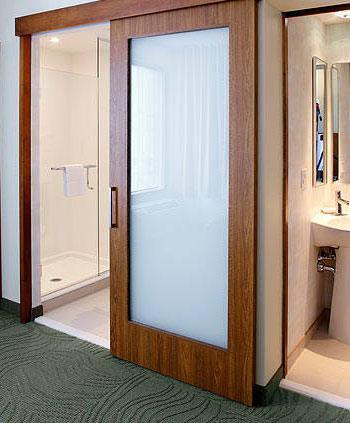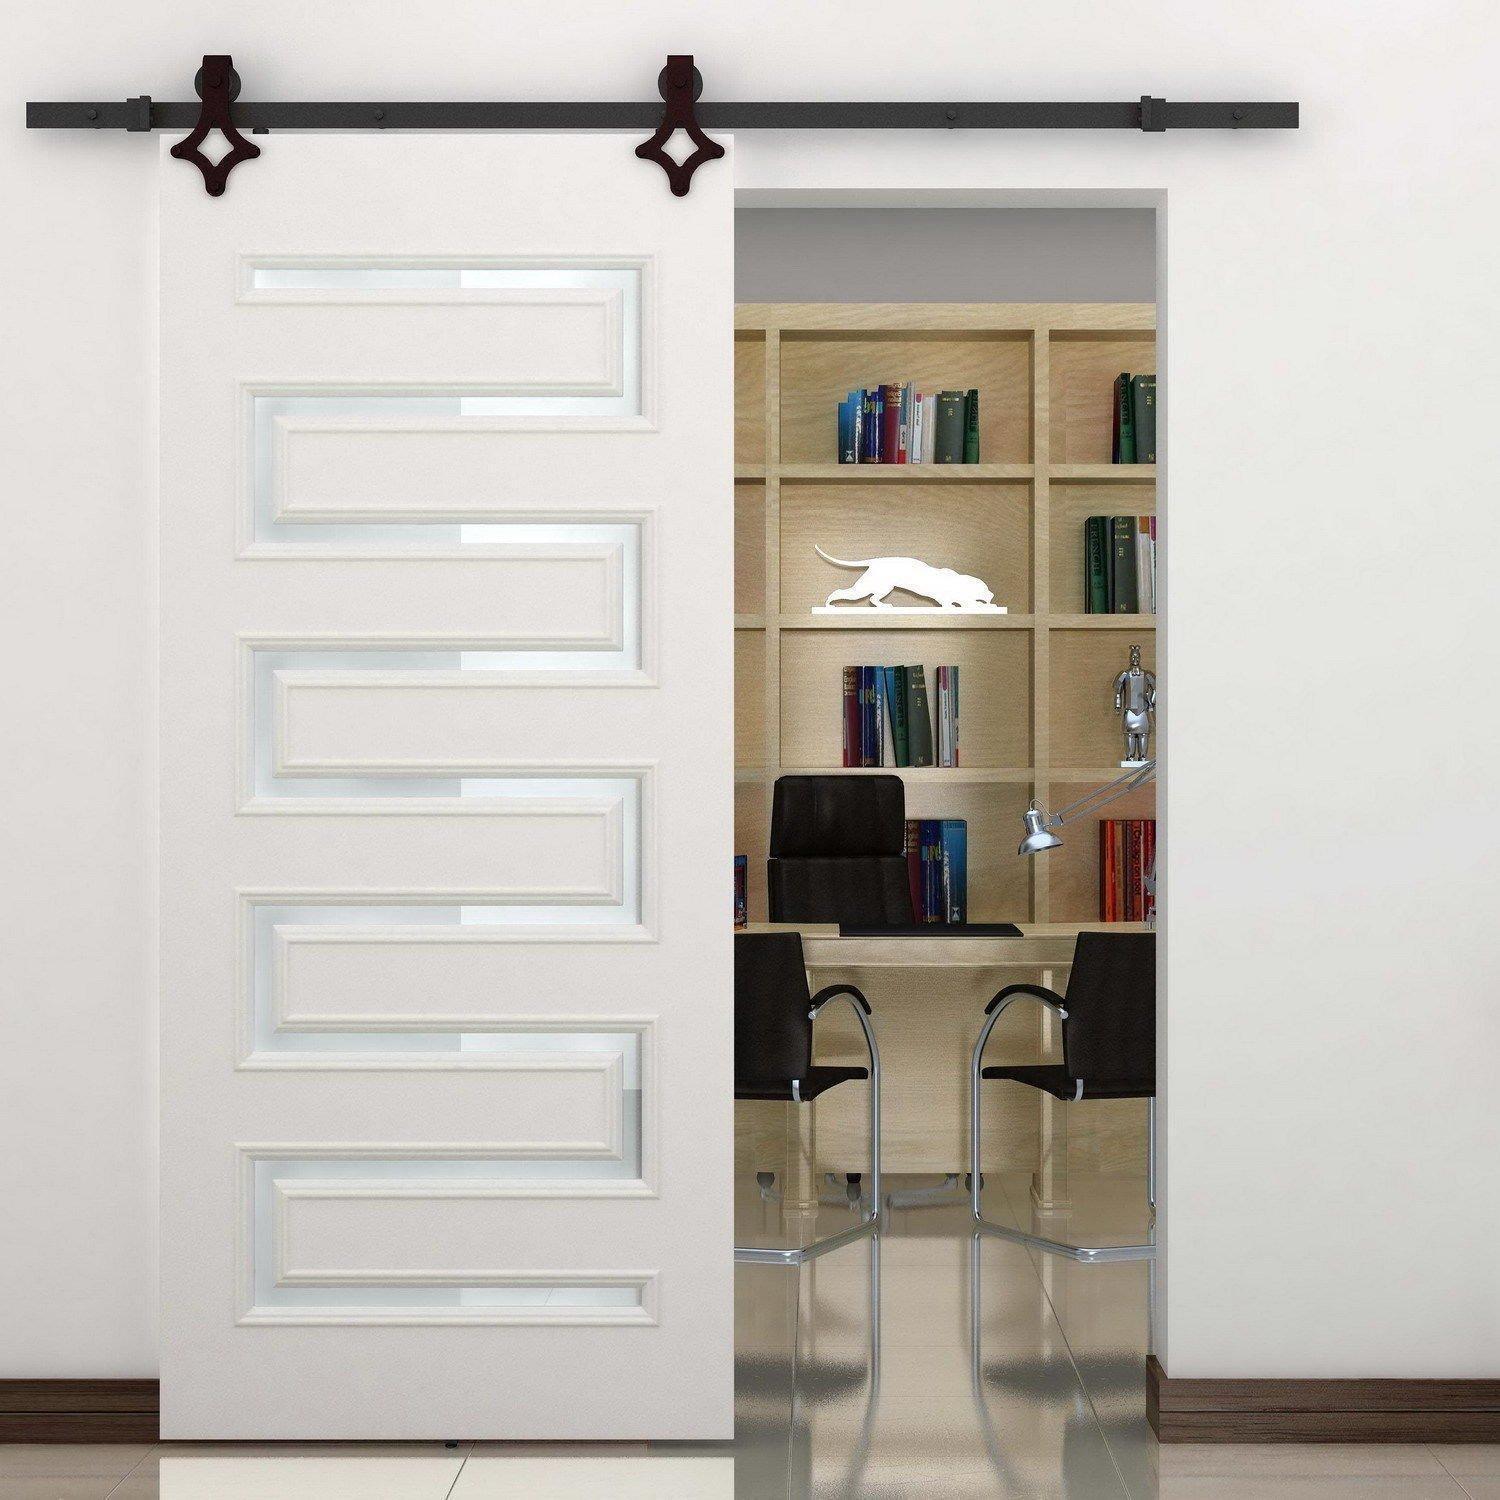The first image is the image on the left, the second image is the image on the right. Examine the images to the left and right. Is the description "In at least one image there is a single hanging wooden door." accurate? Answer yes or no. Yes. The first image is the image on the left, the second image is the image on the right. Given the left and right images, does the statement "One image shows a sliding door wardrobe that sits against a wall and has two dark wood sections and one section that is not dark." hold true? Answer yes or no. No. 